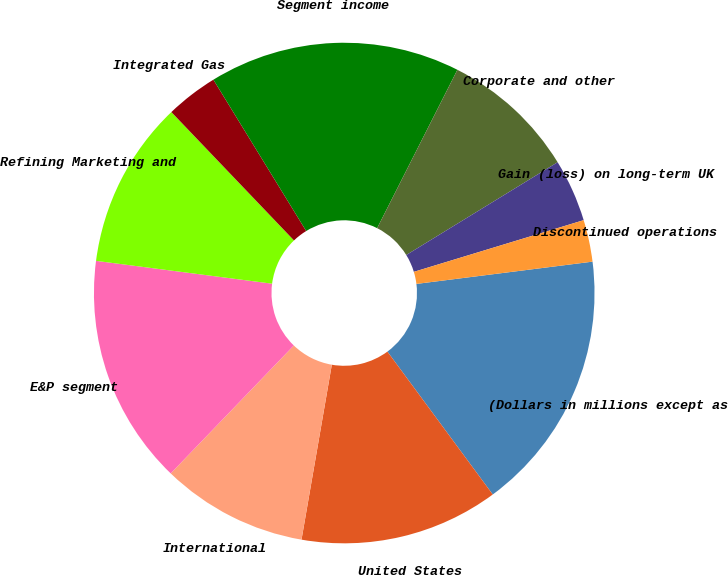Convert chart. <chart><loc_0><loc_0><loc_500><loc_500><pie_chart><fcel>(Dollars in millions except as<fcel>United States<fcel>International<fcel>E&P segment<fcel>Refining Marketing and<fcel>Integrated Gas<fcel>Segment income<fcel>Corporate and other<fcel>Gain (loss) on long-term UK<fcel>Discontinued operations<nl><fcel>16.89%<fcel>12.84%<fcel>9.46%<fcel>14.86%<fcel>10.81%<fcel>3.38%<fcel>16.22%<fcel>8.78%<fcel>4.05%<fcel>2.7%<nl></chart> 